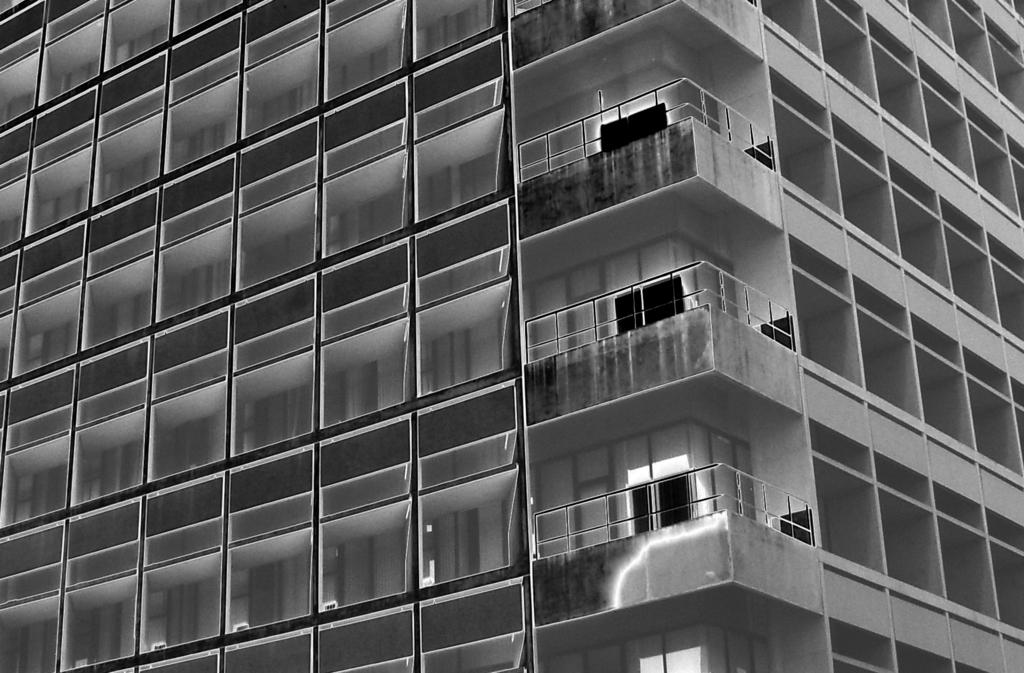What is the main structure in the picture? There is a building in the picture. What are some features of the building? The building has many windows and glass elements. Are there any safety features visible on the building? Yes, there is a railing at the corner of every floor of the building's floors. What type of apple is being used as a doorstop in the image? There is no apple present in the image, and therefore no such object is being used as a doorstop. 